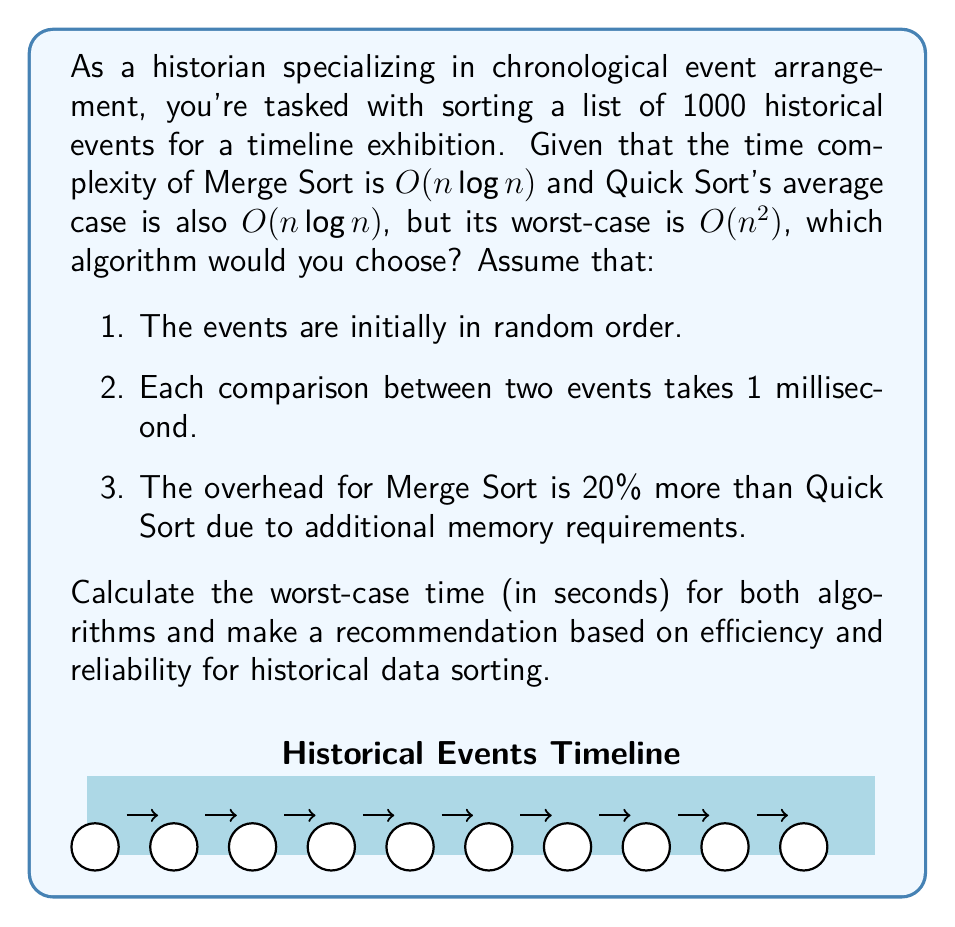Can you answer this question? Let's break this down step-by-step:

1) First, let's calculate the number of comparisons for each algorithm in the worst case:

   Merge Sort: $n \log n = 1000 \log 1000 \approx 9966$ comparisons
   Quick Sort (worst case): $n^2 = 1000^2 = 1,000,000$ comparisons

2) Now, let's convert these comparisons to time:

   Merge Sort: $9966 \times 1 \text{ ms} = 9.966 \text{ seconds}$
   Quick Sort: $1,000,000 \times 1 \text{ ms} = 1000 \text{ seconds}$

3) Accounting for the 20% overhead for Merge Sort:

   Merge Sort (with overhead): $9.966 \times 1.2 = 11.9592 \text{ seconds}$

4) Comparing the worst-case scenarios:

   Merge Sort: 11.9592 seconds
   Quick Sort: 1000 seconds

5) Analysis:
   - Merge Sort guarantees $O(n \log n)$ performance in all cases, which is crucial for reliability in historical data sorting.
   - Quick Sort's worst-case performance is significantly slower, which could be problematic if the historical data has certain patterns (e.g., already partially sorted).
   - The overhead for Merge Sort is negligible compared to the potential worst-case scenario of Quick Sort.

Therefore, despite the slight overhead, Merge Sort is the recommended algorithm for this task due to its consistent performance and reliability when dealing with historical data.
Answer: Merge Sort, 11.9592 seconds worst-case 